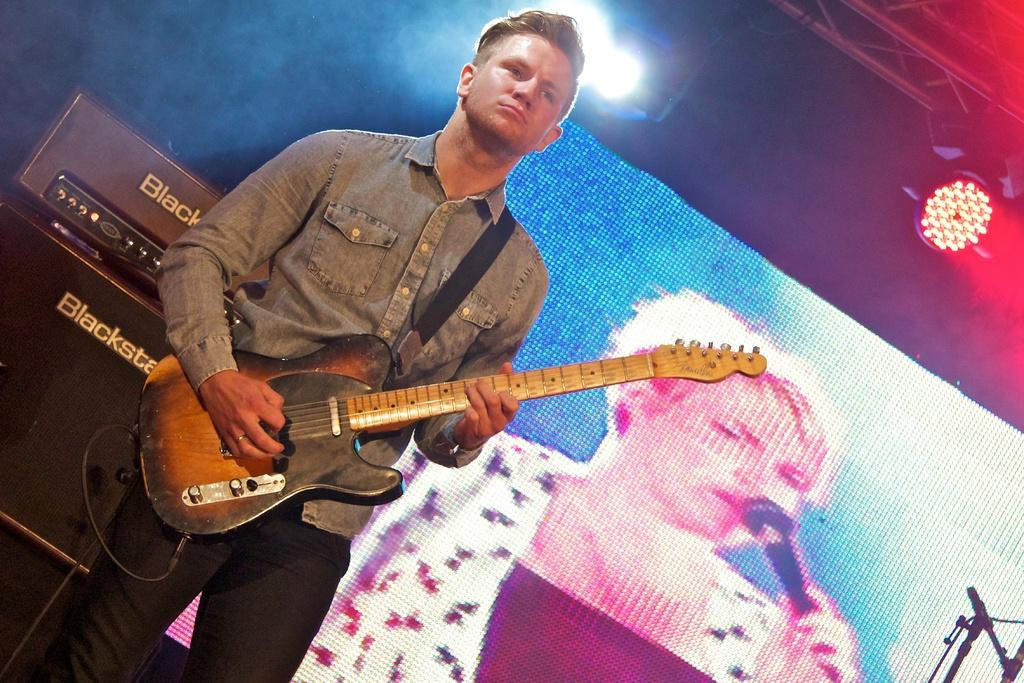What is the person in the image doing? The person is playing a guitar. What can be seen in the background of the image? There is a screen, light, and a pole in the background of the image. What type of steel is used to construct the wall in the image? There is no wall present in the image, so it is not possible to determine what type of steel might be used. 